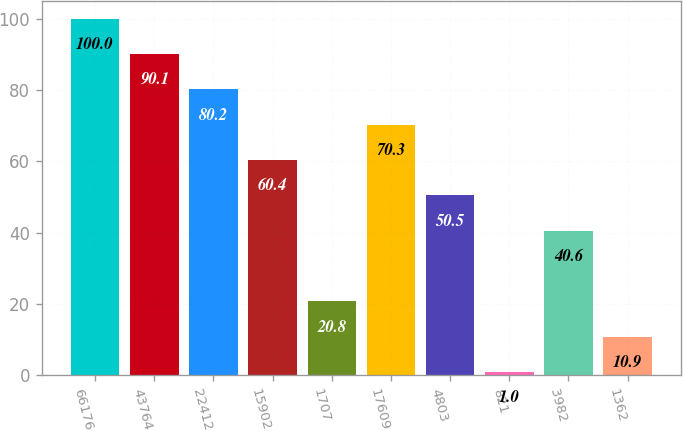Convert chart. <chart><loc_0><loc_0><loc_500><loc_500><bar_chart><fcel>66176<fcel>43764<fcel>22412<fcel>15902<fcel>1707<fcel>17609<fcel>4803<fcel>821<fcel>3982<fcel>1362<nl><fcel>100<fcel>90.1<fcel>80.2<fcel>60.4<fcel>20.8<fcel>70.3<fcel>50.5<fcel>1<fcel>40.6<fcel>10.9<nl></chart> 